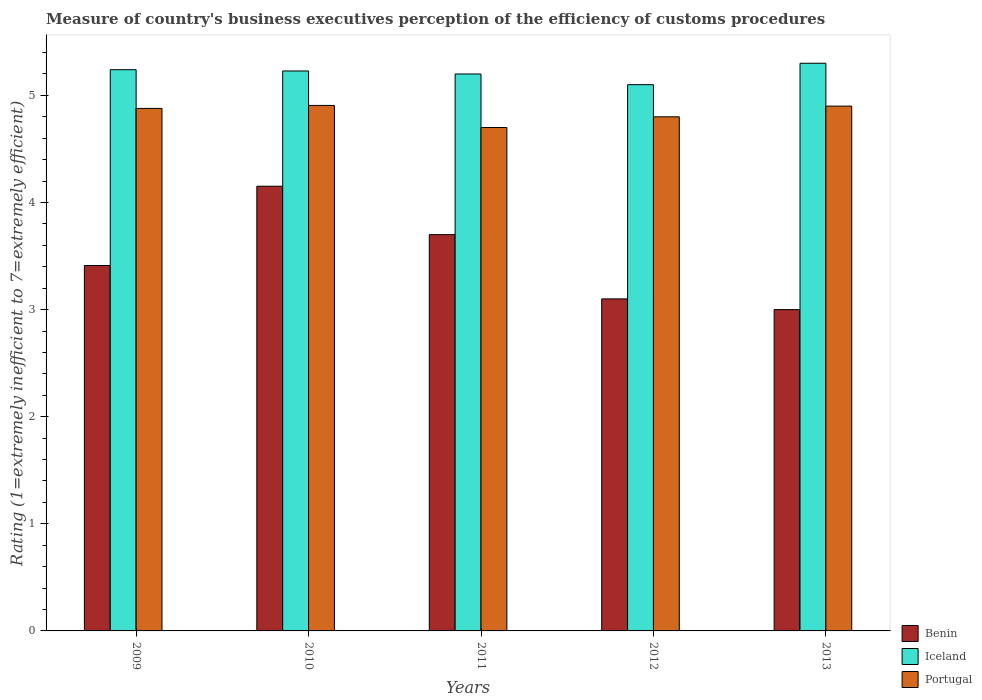Are the number of bars per tick equal to the number of legend labels?
Give a very brief answer. Yes. Are the number of bars on each tick of the X-axis equal?
Offer a very short reply. Yes. What is the label of the 4th group of bars from the left?
Make the answer very short. 2012. In how many cases, is the number of bars for a given year not equal to the number of legend labels?
Your answer should be compact. 0. Across all years, what is the minimum rating of the efficiency of customs procedure in Portugal?
Keep it short and to the point. 4.7. In which year was the rating of the efficiency of customs procedure in Benin maximum?
Offer a very short reply. 2010. What is the total rating of the efficiency of customs procedure in Iceland in the graph?
Your answer should be compact. 26.07. What is the difference between the rating of the efficiency of customs procedure in Iceland in 2009 and that in 2010?
Keep it short and to the point. 0.01. What is the difference between the rating of the efficiency of customs procedure in Portugal in 2011 and the rating of the efficiency of customs procedure in Benin in 2009?
Provide a short and direct response. 1.29. What is the average rating of the efficiency of customs procedure in Iceland per year?
Your answer should be very brief. 5.21. In the year 2012, what is the difference between the rating of the efficiency of customs procedure in Portugal and rating of the efficiency of customs procedure in Benin?
Provide a short and direct response. 1.7. In how many years, is the rating of the efficiency of customs procedure in Portugal greater than 4.2?
Provide a short and direct response. 5. What is the ratio of the rating of the efficiency of customs procedure in Portugal in 2009 to that in 2012?
Your answer should be very brief. 1.02. Is the rating of the efficiency of customs procedure in Iceland in 2012 less than that in 2013?
Ensure brevity in your answer.  Yes. What is the difference between the highest and the second highest rating of the efficiency of customs procedure in Benin?
Give a very brief answer. 0.45. What is the difference between the highest and the lowest rating of the efficiency of customs procedure in Benin?
Offer a very short reply. 1.15. In how many years, is the rating of the efficiency of customs procedure in Benin greater than the average rating of the efficiency of customs procedure in Benin taken over all years?
Make the answer very short. 2. Is the sum of the rating of the efficiency of customs procedure in Iceland in 2010 and 2012 greater than the maximum rating of the efficiency of customs procedure in Portugal across all years?
Ensure brevity in your answer.  Yes. What does the 3rd bar from the left in 2011 represents?
Keep it short and to the point. Portugal. What does the 1st bar from the right in 2013 represents?
Your answer should be very brief. Portugal. Is it the case that in every year, the sum of the rating of the efficiency of customs procedure in Benin and rating of the efficiency of customs procedure in Iceland is greater than the rating of the efficiency of customs procedure in Portugal?
Give a very brief answer. Yes. How many years are there in the graph?
Your answer should be compact. 5. Does the graph contain any zero values?
Make the answer very short. No. Where does the legend appear in the graph?
Provide a succinct answer. Bottom right. How are the legend labels stacked?
Give a very brief answer. Vertical. What is the title of the graph?
Keep it short and to the point. Measure of country's business executives perception of the efficiency of customs procedures. What is the label or title of the Y-axis?
Offer a terse response. Rating (1=extremely inefficient to 7=extremely efficient). What is the Rating (1=extremely inefficient to 7=extremely efficient) of Benin in 2009?
Provide a succinct answer. 3.41. What is the Rating (1=extremely inefficient to 7=extremely efficient) in Iceland in 2009?
Ensure brevity in your answer.  5.24. What is the Rating (1=extremely inefficient to 7=extremely efficient) in Portugal in 2009?
Your response must be concise. 4.88. What is the Rating (1=extremely inefficient to 7=extremely efficient) of Benin in 2010?
Give a very brief answer. 4.15. What is the Rating (1=extremely inefficient to 7=extremely efficient) in Iceland in 2010?
Offer a terse response. 5.23. What is the Rating (1=extremely inefficient to 7=extremely efficient) of Portugal in 2010?
Provide a short and direct response. 4.91. What is the Rating (1=extremely inefficient to 7=extremely efficient) of Benin in 2011?
Give a very brief answer. 3.7. What is the Rating (1=extremely inefficient to 7=extremely efficient) of Iceland in 2012?
Provide a succinct answer. 5.1. What is the Rating (1=extremely inefficient to 7=extremely efficient) of Portugal in 2012?
Offer a very short reply. 4.8. Across all years, what is the maximum Rating (1=extremely inefficient to 7=extremely efficient) of Benin?
Your response must be concise. 4.15. Across all years, what is the maximum Rating (1=extremely inefficient to 7=extremely efficient) in Portugal?
Provide a short and direct response. 4.91. What is the total Rating (1=extremely inefficient to 7=extremely efficient) in Benin in the graph?
Make the answer very short. 17.36. What is the total Rating (1=extremely inefficient to 7=extremely efficient) in Iceland in the graph?
Give a very brief answer. 26.07. What is the total Rating (1=extremely inefficient to 7=extremely efficient) of Portugal in the graph?
Provide a short and direct response. 24.18. What is the difference between the Rating (1=extremely inefficient to 7=extremely efficient) of Benin in 2009 and that in 2010?
Your response must be concise. -0.74. What is the difference between the Rating (1=extremely inefficient to 7=extremely efficient) in Iceland in 2009 and that in 2010?
Ensure brevity in your answer.  0.01. What is the difference between the Rating (1=extremely inefficient to 7=extremely efficient) of Portugal in 2009 and that in 2010?
Keep it short and to the point. -0.03. What is the difference between the Rating (1=extremely inefficient to 7=extremely efficient) of Benin in 2009 and that in 2011?
Offer a very short reply. -0.29. What is the difference between the Rating (1=extremely inefficient to 7=extremely efficient) of Iceland in 2009 and that in 2011?
Offer a terse response. 0.04. What is the difference between the Rating (1=extremely inefficient to 7=extremely efficient) of Portugal in 2009 and that in 2011?
Make the answer very short. 0.18. What is the difference between the Rating (1=extremely inefficient to 7=extremely efficient) of Benin in 2009 and that in 2012?
Your answer should be compact. 0.31. What is the difference between the Rating (1=extremely inefficient to 7=extremely efficient) in Iceland in 2009 and that in 2012?
Provide a succinct answer. 0.14. What is the difference between the Rating (1=extremely inefficient to 7=extremely efficient) of Portugal in 2009 and that in 2012?
Your answer should be very brief. 0.08. What is the difference between the Rating (1=extremely inefficient to 7=extremely efficient) in Benin in 2009 and that in 2013?
Keep it short and to the point. 0.41. What is the difference between the Rating (1=extremely inefficient to 7=extremely efficient) of Iceland in 2009 and that in 2013?
Offer a terse response. -0.06. What is the difference between the Rating (1=extremely inefficient to 7=extremely efficient) of Portugal in 2009 and that in 2013?
Make the answer very short. -0.02. What is the difference between the Rating (1=extremely inefficient to 7=extremely efficient) of Benin in 2010 and that in 2011?
Your answer should be compact. 0.45. What is the difference between the Rating (1=extremely inefficient to 7=extremely efficient) of Iceland in 2010 and that in 2011?
Give a very brief answer. 0.03. What is the difference between the Rating (1=extremely inefficient to 7=extremely efficient) of Portugal in 2010 and that in 2011?
Make the answer very short. 0.21. What is the difference between the Rating (1=extremely inefficient to 7=extremely efficient) of Benin in 2010 and that in 2012?
Offer a terse response. 1.05. What is the difference between the Rating (1=extremely inefficient to 7=extremely efficient) in Iceland in 2010 and that in 2012?
Offer a very short reply. 0.13. What is the difference between the Rating (1=extremely inefficient to 7=extremely efficient) in Portugal in 2010 and that in 2012?
Make the answer very short. 0.11. What is the difference between the Rating (1=extremely inefficient to 7=extremely efficient) in Benin in 2010 and that in 2013?
Your answer should be very brief. 1.15. What is the difference between the Rating (1=extremely inefficient to 7=extremely efficient) of Iceland in 2010 and that in 2013?
Provide a short and direct response. -0.07. What is the difference between the Rating (1=extremely inefficient to 7=extremely efficient) in Portugal in 2010 and that in 2013?
Your response must be concise. 0.01. What is the difference between the Rating (1=extremely inefficient to 7=extremely efficient) of Portugal in 2011 and that in 2012?
Provide a succinct answer. -0.1. What is the difference between the Rating (1=extremely inefficient to 7=extremely efficient) of Benin in 2011 and that in 2013?
Offer a very short reply. 0.7. What is the difference between the Rating (1=extremely inefficient to 7=extremely efficient) of Iceland in 2011 and that in 2013?
Offer a terse response. -0.1. What is the difference between the Rating (1=extremely inefficient to 7=extremely efficient) of Iceland in 2012 and that in 2013?
Offer a very short reply. -0.2. What is the difference between the Rating (1=extremely inefficient to 7=extremely efficient) in Benin in 2009 and the Rating (1=extremely inefficient to 7=extremely efficient) in Iceland in 2010?
Make the answer very short. -1.82. What is the difference between the Rating (1=extremely inefficient to 7=extremely efficient) in Benin in 2009 and the Rating (1=extremely inefficient to 7=extremely efficient) in Portugal in 2010?
Give a very brief answer. -1.49. What is the difference between the Rating (1=extremely inefficient to 7=extremely efficient) of Iceland in 2009 and the Rating (1=extremely inefficient to 7=extremely efficient) of Portugal in 2010?
Make the answer very short. 0.33. What is the difference between the Rating (1=extremely inefficient to 7=extremely efficient) of Benin in 2009 and the Rating (1=extremely inefficient to 7=extremely efficient) of Iceland in 2011?
Your response must be concise. -1.79. What is the difference between the Rating (1=extremely inefficient to 7=extremely efficient) of Benin in 2009 and the Rating (1=extremely inefficient to 7=extremely efficient) of Portugal in 2011?
Your answer should be compact. -1.29. What is the difference between the Rating (1=extremely inefficient to 7=extremely efficient) in Iceland in 2009 and the Rating (1=extremely inefficient to 7=extremely efficient) in Portugal in 2011?
Provide a succinct answer. 0.54. What is the difference between the Rating (1=extremely inefficient to 7=extremely efficient) in Benin in 2009 and the Rating (1=extremely inefficient to 7=extremely efficient) in Iceland in 2012?
Keep it short and to the point. -1.69. What is the difference between the Rating (1=extremely inefficient to 7=extremely efficient) in Benin in 2009 and the Rating (1=extremely inefficient to 7=extremely efficient) in Portugal in 2012?
Offer a very short reply. -1.39. What is the difference between the Rating (1=extremely inefficient to 7=extremely efficient) of Iceland in 2009 and the Rating (1=extremely inefficient to 7=extremely efficient) of Portugal in 2012?
Your answer should be compact. 0.44. What is the difference between the Rating (1=extremely inefficient to 7=extremely efficient) in Benin in 2009 and the Rating (1=extremely inefficient to 7=extremely efficient) in Iceland in 2013?
Make the answer very short. -1.89. What is the difference between the Rating (1=extremely inefficient to 7=extremely efficient) in Benin in 2009 and the Rating (1=extremely inefficient to 7=extremely efficient) in Portugal in 2013?
Make the answer very short. -1.49. What is the difference between the Rating (1=extremely inefficient to 7=extremely efficient) in Iceland in 2009 and the Rating (1=extremely inefficient to 7=extremely efficient) in Portugal in 2013?
Provide a short and direct response. 0.34. What is the difference between the Rating (1=extremely inefficient to 7=extremely efficient) in Benin in 2010 and the Rating (1=extremely inefficient to 7=extremely efficient) in Iceland in 2011?
Your answer should be very brief. -1.05. What is the difference between the Rating (1=extremely inefficient to 7=extremely efficient) of Benin in 2010 and the Rating (1=extremely inefficient to 7=extremely efficient) of Portugal in 2011?
Make the answer very short. -0.55. What is the difference between the Rating (1=extremely inefficient to 7=extremely efficient) in Iceland in 2010 and the Rating (1=extremely inefficient to 7=extremely efficient) in Portugal in 2011?
Your response must be concise. 0.53. What is the difference between the Rating (1=extremely inefficient to 7=extremely efficient) in Benin in 2010 and the Rating (1=extremely inefficient to 7=extremely efficient) in Iceland in 2012?
Offer a terse response. -0.95. What is the difference between the Rating (1=extremely inefficient to 7=extremely efficient) in Benin in 2010 and the Rating (1=extremely inefficient to 7=extremely efficient) in Portugal in 2012?
Provide a short and direct response. -0.65. What is the difference between the Rating (1=extremely inefficient to 7=extremely efficient) of Iceland in 2010 and the Rating (1=extremely inefficient to 7=extremely efficient) of Portugal in 2012?
Your answer should be compact. 0.43. What is the difference between the Rating (1=extremely inefficient to 7=extremely efficient) of Benin in 2010 and the Rating (1=extremely inefficient to 7=extremely efficient) of Iceland in 2013?
Provide a succinct answer. -1.15. What is the difference between the Rating (1=extremely inefficient to 7=extremely efficient) in Benin in 2010 and the Rating (1=extremely inefficient to 7=extremely efficient) in Portugal in 2013?
Ensure brevity in your answer.  -0.75. What is the difference between the Rating (1=extremely inefficient to 7=extremely efficient) of Iceland in 2010 and the Rating (1=extremely inefficient to 7=extremely efficient) of Portugal in 2013?
Offer a terse response. 0.33. What is the difference between the Rating (1=extremely inefficient to 7=extremely efficient) in Benin in 2011 and the Rating (1=extremely inefficient to 7=extremely efficient) in Iceland in 2012?
Offer a very short reply. -1.4. What is the difference between the Rating (1=extremely inefficient to 7=extremely efficient) in Benin in 2011 and the Rating (1=extremely inefficient to 7=extremely efficient) in Portugal in 2012?
Offer a terse response. -1.1. What is the difference between the Rating (1=extremely inefficient to 7=extremely efficient) of Iceland in 2011 and the Rating (1=extremely inefficient to 7=extremely efficient) of Portugal in 2012?
Ensure brevity in your answer.  0.4. What is the difference between the Rating (1=extremely inefficient to 7=extremely efficient) in Benin in 2011 and the Rating (1=extremely inefficient to 7=extremely efficient) in Portugal in 2013?
Make the answer very short. -1.2. What is the difference between the Rating (1=extremely inefficient to 7=extremely efficient) in Iceland in 2012 and the Rating (1=extremely inefficient to 7=extremely efficient) in Portugal in 2013?
Ensure brevity in your answer.  0.2. What is the average Rating (1=extremely inefficient to 7=extremely efficient) in Benin per year?
Provide a short and direct response. 3.47. What is the average Rating (1=extremely inefficient to 7=extremely efficient) of Iceland per year?
Make the answer very short. 5.21. What is the average Rating (1=extremely inefficient to 7=extremely efficient) of Portugal per year?
Provide a short and direct response. 4.84. In the year 2009, what is the difference between the Rating (1=extremely inefficient to 7=extremely efficient) of Benin and Rating (1=extremely inefficient to 7=extremely efficient) of Iceland?
Provide a succinct answer. -1.83. In the year 2009, what is the difference between the Rating (1=extremely inefficient to 7=extremely efficient) of Benin and Rating (1=extremely inefficient to 7=extremely efficient) of Portugal?
Offer a very short reply. -1.47. In the year 2009, what is the difference between the Rating (1=extremely inefficient to 7=extremely efficient) in Iceland and Rating (1=extremely inefficient to 7=extremely efficient) in Portugal?
Offer a very short reply. 0.36. In the year 2010, what is the difference between the Rating (1=extremely inefficient to 7=extremely efficient) of Benin and Rating (1=extremely inefficient to 7=extremely efficient) of Iceland?
Make the answer very short. -1.08. In the year 2010, what is the difference between the Rating (1=extremely inefficient to 7=extremely efficient) of Benin and Rating (1=extremely inefficient to 7=extremely efficient) of Portugal?
Provide a short and direct response. -0.75. In the year 2010, what is the difference between the Rating (1=extremely inefficient to 7=extremely efficient) of Iceland and Rating (1=extremely inefficient to 7=extremely efficient) of Portugal?
Offer a very short reply. 0.32. In the year 2011, what is the difference between the Rating (1=extremely inefficient to 7=extremely efficient) of Benin and Rating (1=extremely inefficient to 7=extremely efficient) of Iceland?
Provide a succinct answer. -1.5. In the year 2011, what is the difference between the Rating (1=extremely inefficient to 7=extremely efficient) in Benin and Rating (1=extremely inefficient to 7=extremely efficient) in Portugal?
Keep it short and to the point. -1. In the year 2011, what is the difference between the Rating (1=extremely inefficient to 7=extremely efficient) of Iceland and Rating (1=extremely inefficient to 7=extremely efficient) of Portugal?
Keep it short and to the point. 0.5. In the year 2012, what is the difference between the Rating (1=extremely inefficient to 7=extremely efficient) in Benin and Rating (1=extremely inefficient to 7=extremely efficient) in Portugal?
Ensure brevity in your answer.  -1.7. In the year 2012, what is the difference between the Rating (1=extremely inefficient to 7=extremely efficient) of Iceland and Rating (1=extremely inefficient to 7=extremely efficient) of Portugal?
Ensure brevity in your answer.  0.3. In the year 2013, what is the difference between the Rating (1=extremely inefficient to 7=extremely efficient) of Benin and Rating (1=extremely inefficient to 7=extremely efficient) of Iceland?
Your answer should be very brief. -2.3. In the year 2013, what is the difference between the Rating (1=extremely inefficient to 7=extremely efficient) of Benin and Rating (1=extremely inefficient to 7=extremely efficient) of Portugal?
Ensure brevity in your answer.  -1.9. In the year 2013, what is the difference between the Rating (1=extremely inefficient to 7=extremely efficient) of Iceland and Rating (1=extremely inefficient to 7=extremely efficient) of Portugal?
Ensure brevity in your answer.  0.4. What is the ratio of the Rating (1=extremely inefficient to 7=extremely efficient) of Benin in 2009 to that in 2010?
Provide a succinct answer. 0.82. What is the ratio of the Rating (1=extremely inefficient to 7=extremely efficient) of Iceland in 2009 to that in 2010?
Ensure brevity in your answer.  1. What is the ratio of the Rating (1=extremely inefficient to 7=extremely efficient) of Portugal in 2009 to that in 2010?
Give a very brief answer. 0.99. What is the ratio of the Rating (1=extremely inefficient to 7=extremely efficient) in Benin in 2009 to that in 2011?
Make the answer very short. 0.92. What is the ratio of the Rating (1=extremely inefficient to 7=extremely efficient) in Iceland in 2009 to that in 2011?
Your answer should be compact. 1.01. What is the ratio of the Rating (1=extremely inefficient to 7=extremely efficient) in Portugal in 2009 to that in 2011?
Your answer should be compact. 1.04. What is the ratio of the Rating (1=extremely inefficient to 7=extremely efficient) of Benin in 2009 to that in 2012?
Ensure brevity in your answer.  1.1. What is the ratio of the Rating (1=extremely inefficient to 7=extremely efficient) of Iceland in 2009 to that in 2012?
Your response must be concise. 1.03. What is the ratio of the Rating (1=extremely inefficient to 7=extremely efficient) in Portugal in 2009 to that in 2012?
Your response must be concise. 1.02. What is the ratio of the Rating (1=extremely inefficient to 7=extremely efficient) in Benin in 2009 to that in 2013?
Your response must be concise. 1.14. What is the ratio of the Rating (1=extremely inefficient to 7=extremely efficient) in Iceland in 2009 to that in 2013?
Keep it short and to the point. 0.99. What is the ratio of the Rating (1=extremely inefficient to 7=extremely efficient) of Portugal in 2009 to that in 2013?
Your answer should be very brief. 1. What is the ratio of the Rating (1=extremely inefficient to 7=extremely efficient) in Benin in 2010 to that in 2011?
Offer a terse response. 1.12. What is the ratio of the Rating (1=extremely inefficient to 7=extremely efficient) in Iceland in 2010 to that in 2011?
Give a very brief answer. 1.01. What is the ratio of the Rating (1=extremely inefficient to 7=extremely efficient) of Portugal in 2010 to that in 2011?
Your response must be concise. 1.04. What is the ratio of the Rating (1=extremely inefficient to 7=extremely efficient) in Benin in 2010 to that in 2012?
Make the answer very short. 1.34. What is the ratio of the Rating (1=extremely inefficient to 7=extremely efficient) in Iceland in 2010 to that in 2012?
Keep it short and to the point. 1.03. What is the ratio of the Rating (1=extremely inefficient to 7=extremely efficient) in Portugal in 2010 to that in 2012?
Offer a terse response. 1.02. What is the ratio of the Rating (1=extremely inefficient to 7=extremely efficient) of Benin in 2010 to that in 2013?
Provide a succinct answer. 1.38. What is the ratio of the Rating (1=extremely inefficient to 7=extremely efficient) in Iceland in 2010 to that in 2013?
Ensure brevity in your answer.  0.99. What is the ratio of the Rating (1=extremely inefficient to 7=extremely efficient) of Portugal in 2010 to that in 2013?
Your answer should be very brief. 1. What is the ratio of the Rating (1=extremely inefficient to 7=extremely efficient) in Benin in 2011 to that in 2012?
Ensure brevity in your answer.  1.19. What is the ratio of the Rating (1=extremely inefficient to 7=extremely efficient) in Iceland in 2011 to that in 2012?
Provide a short and direct response. 1.02. What is the ratio of the Rating (1=extremely inefficient to 7=extremely efficient) of Portugal in 2011 to that in 2012?
Your response must be concise. 0.98. What is the ratio of the Rating (1=extremely inefficient to 7=extremely efficient) of Benin in 2011 to that in 2013?
Your response must be concise. 1.23. What is the ratio of the Rating (1=extremely inefficient to 7=extremely efficient) in Iceland in 2011 to that in 2013?
Make the answer very short. 0.98. What is the ratio of the Rating (1=extremely inefficient to 7=extremely efficient) of Portugal in 2011 to that in 2013?
Provide a short and direct response. 0.96. What is the ratio of the Rating (1=extremely inefficient to 7=extremely efficient) of Iceland in 2012 to that in 2013?
Make the answer very short. 0.96. What is the ratio of the Rating (1=extremely inefficient to 7=extremely efficient) in Portugal in 2012 to that in 2013?
Offer a very short reply. 0.98. What is the difference between the highest and the second highest Rating (1=extremely inefficient to 7=extremely efficient) of Benin?
Ensure brevity in your answer.  0.45. What is the difference between the highest and the second highest Rating (1=extremely inefficient to 7=extremely efficient) in Iceland?
Keep it short and to the point. 0.06. What is the difference between the highest and the second highest Rating (1=extremely inefficient to 7=extremely efficient) in Portugal?
Provide a succinct answer. 0.01. What is the difference between the highest and the lowest Rating (1=extremely inefficient to 7=extremely efficient) in Benin?
Make the answer very short. 1.15. What is the difference between the highest and the lowest Rating (1=extremely inefficient to 7=extremely efficient) in Iceland?
Provide a succinct answer. 0.2. What is the difference between the highest and the lowest Rating (1=extremely inefficient to 7=extremely efficient) in Portugal?
Offer a very short reply. 0.21. 